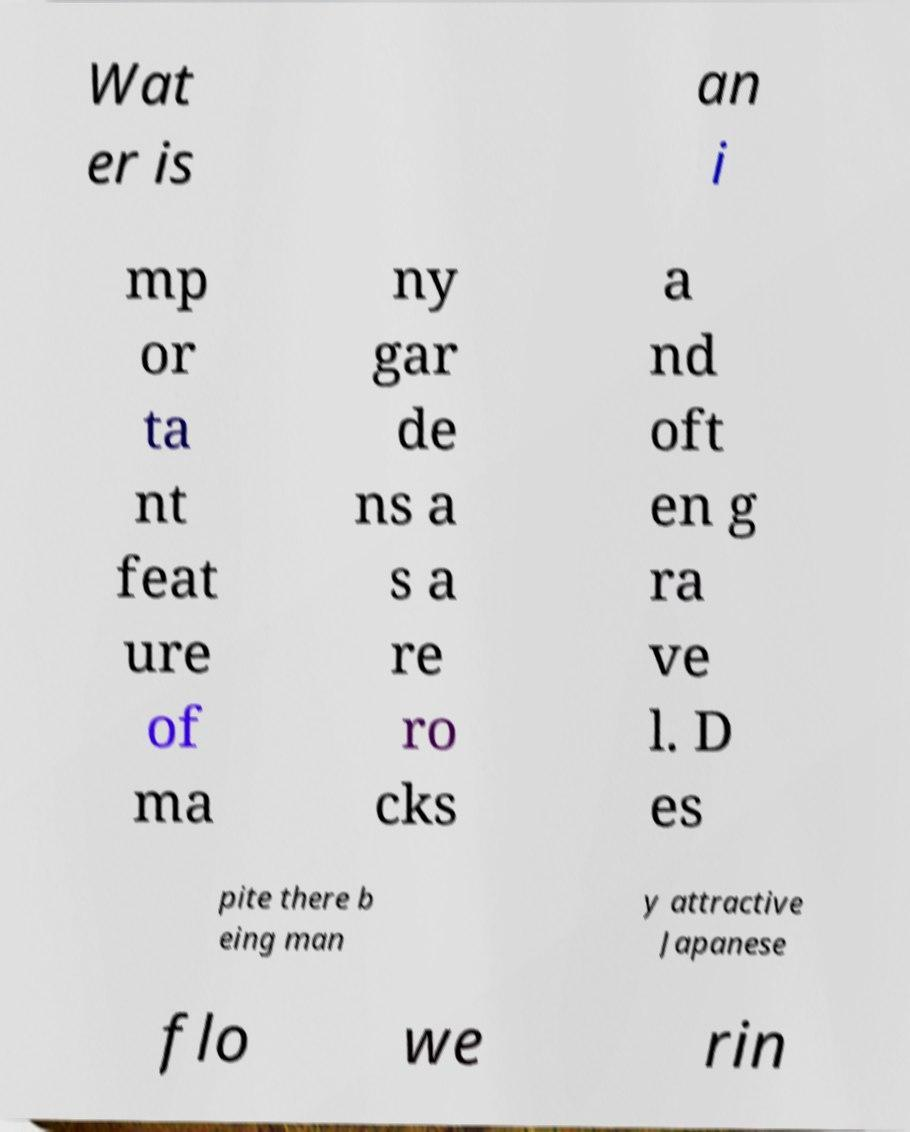Could you assist in decoding the text presented in this image and type it out clearly? Wat er is an i mp or ta nt feat ure of ma ny gar de ns a s a re ro cks a nd oft en g ra ve l. D es pite there b eing man y attractive Japanese flo we rin 